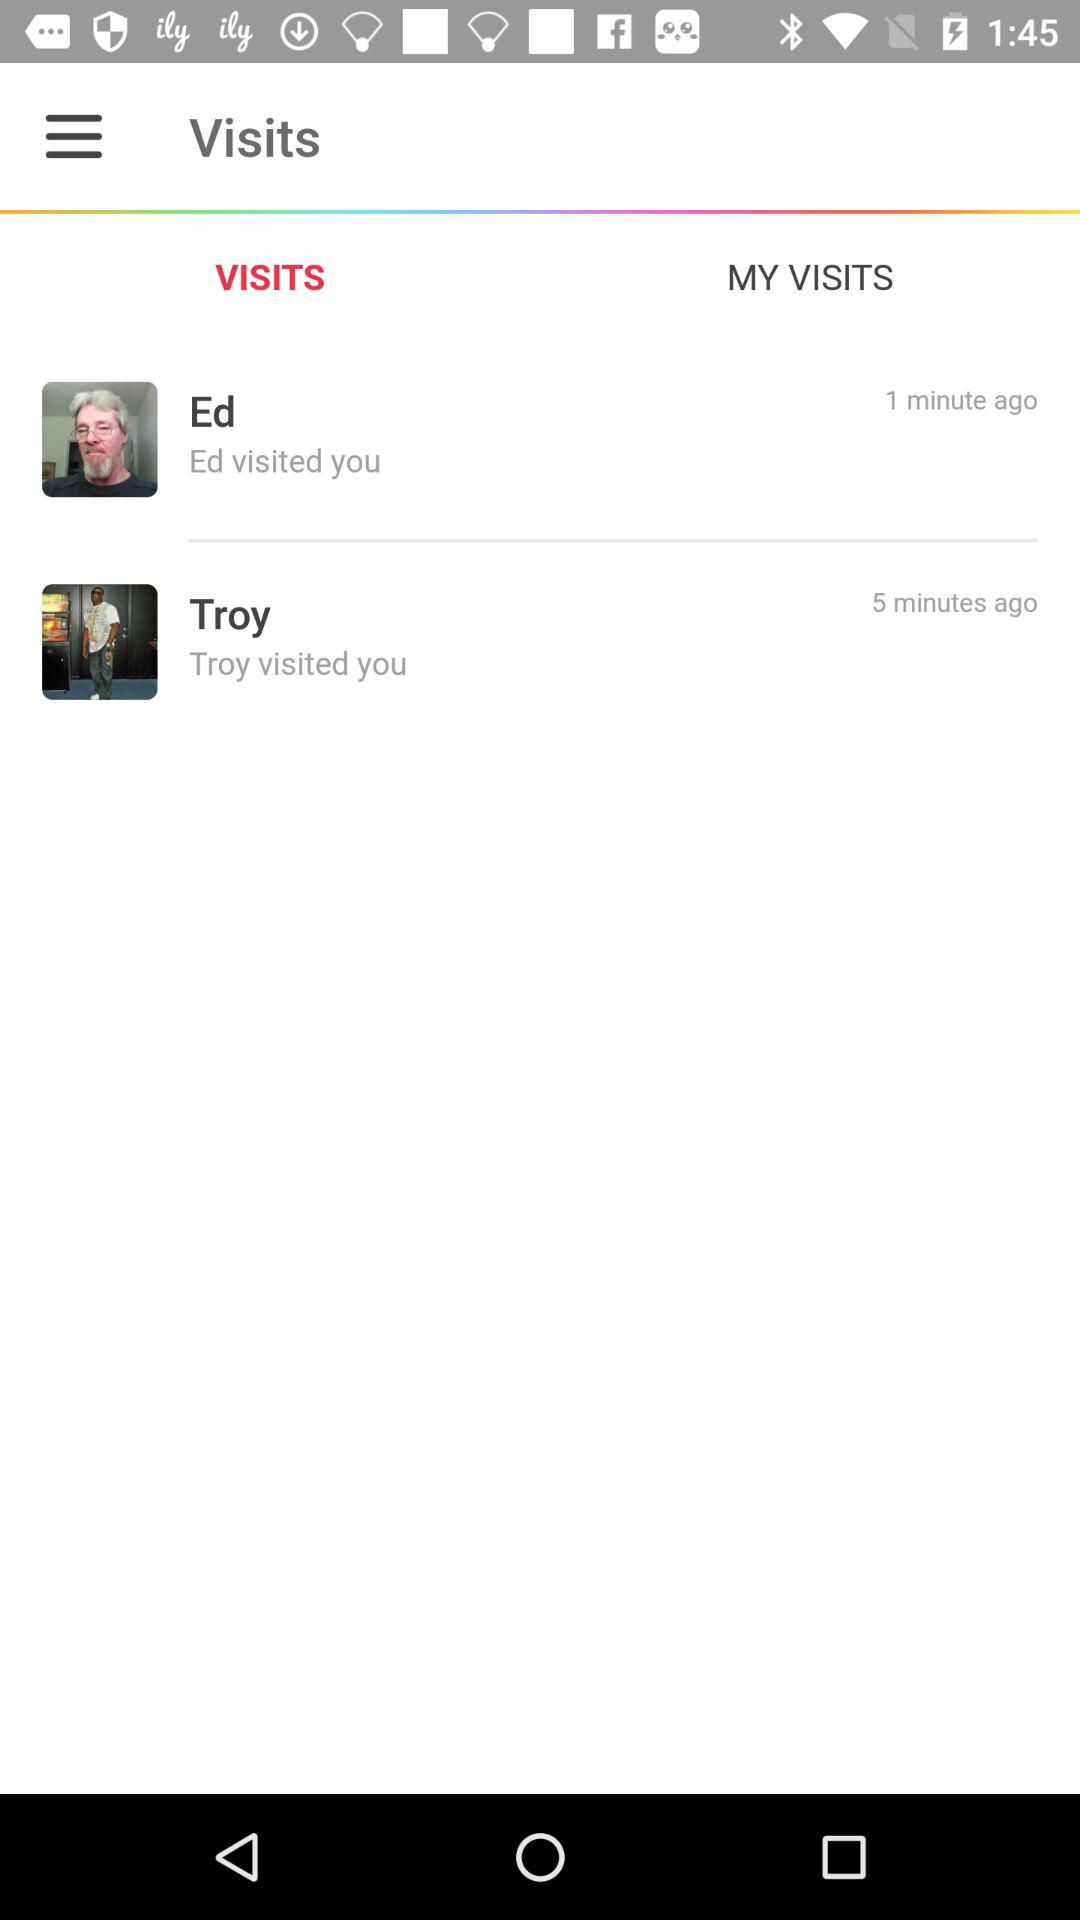How long ago did Ed visit me? Ed visited me 1 minute ago. 